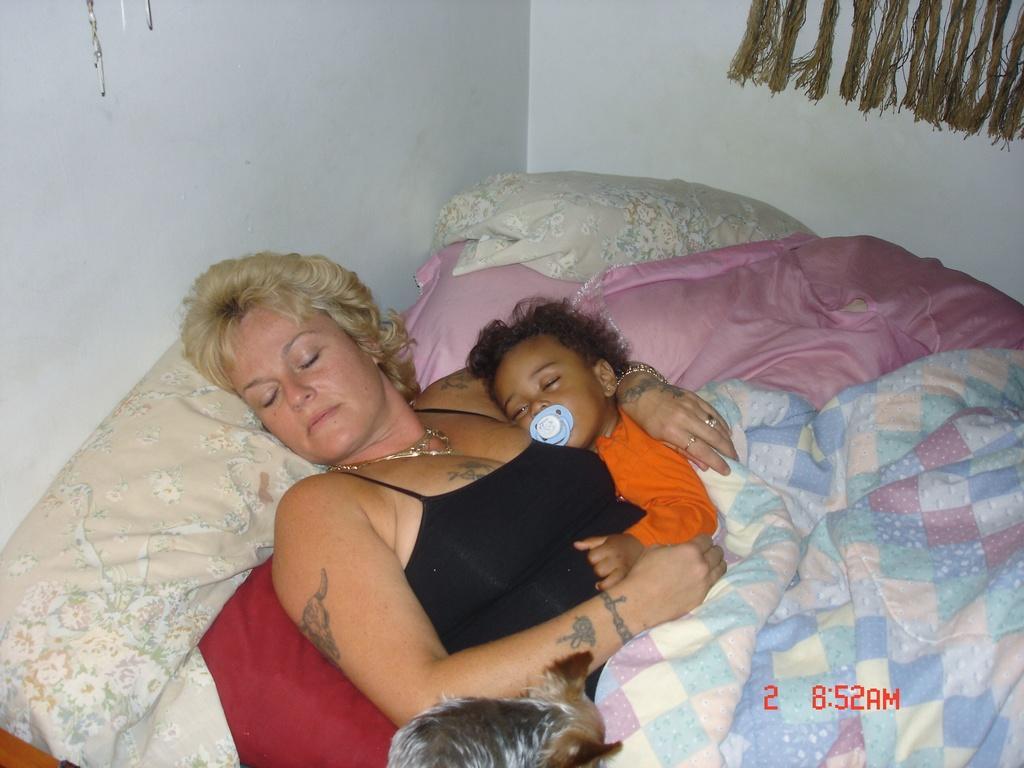How would you summarize this image in a sentence or two? In this image I can see a woman wearing black colored dress and a baby wearing orange colored dress are sleeping on the bed. I can see a dog which is white, black and brown in color, few pillows which are cream in color and the bed sheet which is blue in color on the bed. I can see the white colored wall in the background 